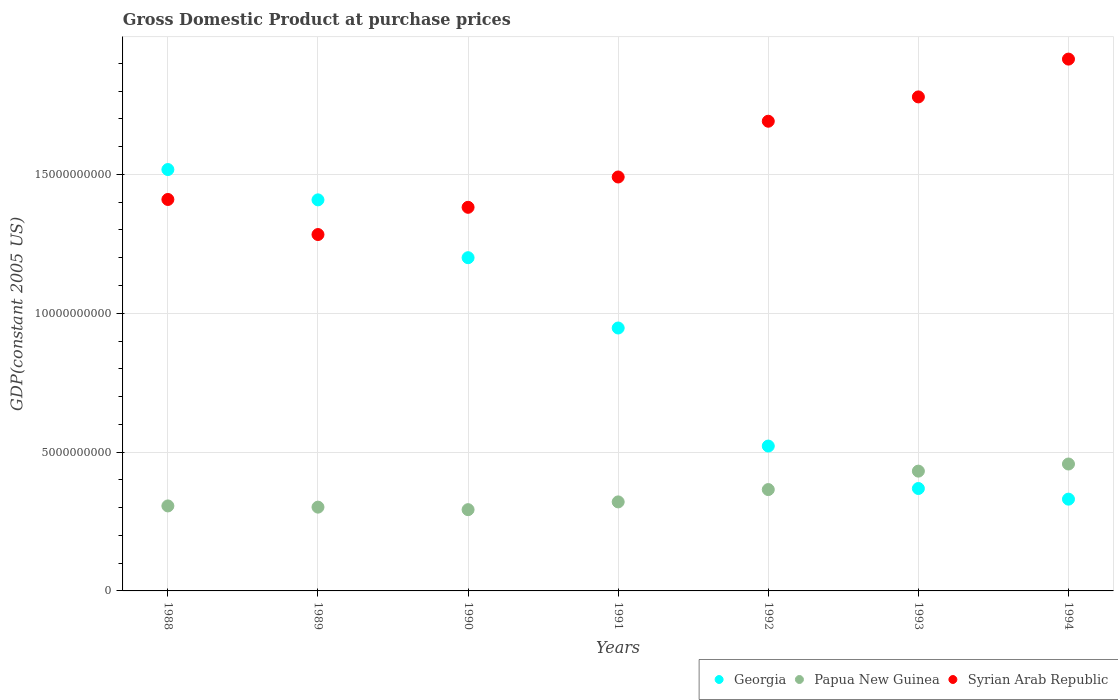How many different coloured dotlines are there?
Provide a short and direct response. 3. Is the number of dotlines equal to the number of legend labels?
Provide a succinct answer. Yes. What is the GDP at purchase prices in Papua New Guinea in 1994?
Your answer should be compact. 4.57e+09. Across all years, what is the maximum GDP at purchase prices in Syrian Arab Republic?
Give a very brief answer. 1.92e+1. Across all years, what is the minimum GDP at purchase prices in Georgia?
Provide a short and direct response. 3.30e+09. What is the total GDP at purchase prices in Georgia in the graph?
Your answer should be compact. 6.29e+1. What is the difference between the GDP at purchase prices in Syrian Arab Republic in 1990 and that in 1991?
Give a very brief answer. -1.09e+09. What is the difference between the GDP at purchase prices in Papua New Guinea in 1991 and the GDP at purchase prices in Syrian Arab Republic in 1994?
Provide a succinct answer. -1.59e+1. What is the average GDP at purchase prices in Papua New Guinea per year?
Offer a terse response. 3.53e+09. In the year 1992, what is the difference between the GDP at purchase prices in Georgia and GDP at purchase prices in Syrian Arab Republic?
Provide a short and direct response. -1.17e+1. What is the ratio of the GDP at purchase prices in Georgia in 1989 to that in 1990?
Keep it short and to the point. 1.17. Is the GDP at purchase prices in Papua New Guinea in 1989 less than that in 1990?
Your answer should be compact. No. Is the difference between the GDP at purchase prices in Georgia in 1988 and 1993 greater than the difference between the GDP at purchase prices in Syrian Arab Republic in 1988 and 1993?
Offer a terse response. Yes. What is the difference between the highest and the second highest GDP at purchase prices in Syrian Arab Republic?
Provide a short and direct response. 1.36e+09. What is the difference between the highest and the lowest GDP at purchase prices in Papua New Guinea?
Offer a very short reply. 1.64e+09. In how many years, is the GDP at purchase prices in Papua New Guinea greater than the average GDP at purchase prices in Papua New Guinea taken over all years?
Ensure brevity in your answer.  3. Is it the case that in every year, the sum of the GDP at purchase prices in Georgia and GDP at purchase prices in Papua New Guinea  is greater than the GDP at purchase prices in Syrian Arab Republic?
Give a very brief answer. No. Does the GDP at purchase prices in Papua New Guinea monotonically increase over the years?
Your response must be concise. No. Is the GDP at purchase prices in Georgia strictly greater than the GDP at purchase prices in Syrian Arab Republic over the years?
Make the answer very short. No. How many years are there in the graph?
Your answer should be compact. 7. Are the values on the major ticks of Y-axis written in scientific E-notation?
Offer a terse response. No. Does the graph contain grids?
Offer a terse response. Yes. What is the title of the graph?
Offer a very short reply. Gross Domestic Product at purchase prices. Does "Panama" appear as one of the legend labels in the graph?
Keep it short and to the point. No. What is the label or title of the Y-axis?
Make the answer very short. GDP(constant 2005 US). What is the GDP(constant 2005 US) in Georgia in 1988?
Make the answer very short. 1.52e+1. What is the GDP(constant 2005 US) of Papua New Guinea in 1988?
Keep it short and to the point. 3.06e+09. What is the GDP(constant 2005 US) of Syrian Arab Republic in 1988?
Offer a very short reply. 1.41e+1. What is the GDP(constant 2005 US) in Georgia in 1989?
Provide a short and direct response. 1.41e+1. What is the GDP(constant 2005 US) of Papua New Guinea in 1989?
Make the answer very short. 3.02e+09. What is the GDP(constant 2005 US) in Syrian Arab Republic in 1989?
Offer a very short reply. 1.28e+1. What is the GDP(constant 2005 US) in Georgia in 1990?
Give a very brief answer. 1.20e+1. What is the GDP(constant 2005 US) in Papua New Guinea in 1990?
Make the answer very short. 2.93e+09. What is the GDP(constant 2005 US) in Syrian Arab Republic in 1990?
Your response must be concise. 1.38e+1. What is the GDP(constant 2005 US) of Georgia in 1991?
Provide a short and direct response. 9.47e+09. What is the GDP(constant 2005 US) of Papua New Guinea in 1991?
Provide a short and direct response. 3.21e+09. What is the GDP(constant 2005 US) in Syrian Arab Republic in 1991?
Ensure brevity in your answer.  1.49e+1. What is the GDP(constant 2005 US) in Georgia in 1992?
Offer a terse response. 5.22e+09. What is the GDP(constant 2005 US) of Papua New Guinea in 1992?
Give a very brief answer. 3.65e+09. What is the GDP(constant 2005 US) in Syrian Arab Republic in 1992?
Your answer should be very brief. 1.69e+1. What is the GDP(constant 2005 US) in Georgia in 1993?
Your answer should be compact. 3.69e+09. What is the GDP(constant 2005 US) of Papua New Guinea in 1993?
Your answer should be compact. 4.31e+09. What is the GDP(constant 2005 US) in Syrian Arab Republic in 1993?
Keep it short and to the point. 1.78e+1. What is the GDP(constant 2005 US) in Georgia in 1994?
Provide a short and direct response. 3.30e+09. What is the GDP(constant 2005 US) of Papua New Guinea in 1994?
Keep it short and to the point. 4.57e+09. What is the GDP(constant 2005 US) of Syrian Arab Republic in 1994?
Your answer should be very brief. 1.92e+1. Across all years, what is the maximum GDP(constant 2005 US) in Georgia?
Give a very brief answer. 1.52e+1. Across all years, what is the maximum GDP(constant 2005 US) in Papua New Guinea?
Give a very brief answer. 4.57e+09. Across all years, what is the maximum GDP(constant 2005 US) in Syrian Arab Republic?
Ensure brevity in your answer.  1.92e+1. Across all years, what is the minimum GDP(constant 2005 US) in Georgia?
Provide a succinct answer. 3.30e+09. Across all years, what is the minimum GDP(constant 2005 US) in Papua New Guinea?
Ensure brevity in your answer.  2.93e+09. Across all years, what is the minimum GDP(constant 2005 US) of Syrian Arab Republic?
Keep it short and to the point. 1.28e+1. What is the total GDP(constant 2005 US) in Georgia in the graph?
Your answer should be very brief. 6.29e+1. What is the total GDP(constant 2005 US) of Papua New Guinea in the graph?
Give a very brief answer. 2.47e+1. What is the total GDP(constant 2005 US) of Syrian Arab Republic in the graph?
Your response must be concise. 1.10e+11. What is the difference between the GDP(constant 2005 US) of Georgia in 1988 and that in 1989?
Offer a very short reply. 1.09e+09. What is the difference between the GDP(constant 2005 US) in Papua New Guinea in 1988 and that in 1989?
Your response must be concise. 4.34e+07. What is the difference between the GDP(constant 2005 US) of Syrian Arab Republic in 1988 and that in 1989?
Your answer should be very brief. 1.26e+09. What is the difference between the GDP(constant 2005 US) in Georgia in 1988 and that in 1990?
Give a very brief answer. 3.17e+09. What is the difference between the GDP(constant 2005 US) of Papua New Guinea in 1988 and that in 1990?
Make the answer very short. 1.34e+08. What is the difference between the GDP(constant 2005 US) of Syrian Arab Republic in 1988 and that in 1990?
Provide a succinct answer. 2.82e+08. What is the difference between the GDP(constant 2005 US) of Georgia in 1988 and that in 1991?
Offer a terse response. 5.71e+09. What is the difference between the GDP(constant 2005 US) in Papua New Guinea in 1988 and that in 1991?
Offer a very short reply. -1.45e+08. What is the difference between the GDP(constant 2005 US) of Syrian Arab Republic in 1988 and that in 1991?
Your answer should be compact. -8.09e+08. What is the difference between the GDP(constant 2005 US) in Georgia in 1988 and that in 1992?
Offer a very short reply. 9.96e+09. What is the difference between the GDP(constant 2005 US) in Papua New Guinea in 1988 and that in 1992?
Your answer should be very brief. -5.89e+08. What is the difference between the GDP(constant 2005 US) of Syrian Arab Republic in 1988 and that in 1992?
Your answer should be very brief. -2.82e+09. What is the difference between the GDP(constant 2005 US) of Georgia in 1988 and that in 1993?
Provide a succinct answer. 1.15e+1. What is the difference between the GDP(constant 2005 US) of Papua New Guinea in 1988 and that in 1993?
Provide a succinct answer. -1.25e+09. What is the difference between the GDP(constant 2005 US) in Syrian Arab Republic in 1988 and that in 1993?
Provide a succinct answer. -3.69e+09. What is the difference between the GDP(constant 2005 US) of Georgia in 1988 and that in 1994?
Keep it short and to the point. 1.19e+1. What is the difference between the GDP(constant 2005 US) of Papua New Guinea in 1988 and that in 1994?
Your answer should be compact. -1.51e+09. What is the difference between the GDP(constant 2005 US) in Syrian Arab Republic in 1988 and that in 1994?
Your response must be concise. -5.05e+09. What is the difference between the GDP(constant 2005 US) of Georgia in 1989 and that in 1990?
Your answer should be compact. 2.08e+09. What is the difference between the GDP(constant 2005 US) of Papua New Guinea in 1989 and that in 1990?
Your answer should be very brief. 9.09e+07. What is the difference between the GDP(constant 2005 US) in Syrian Arab Republic in 1989 and that in 1990?
Keep it short and to the point. -9.81e+08. What is the difference between the GDP(constant 2005 US) in Georgia in 1989 and that in 1991?
Your response must be concise. 4.61e+09. What is the difference between the GDP(constant 2005 US) in Papua New Guinea in 1989 and that in 1991?
Give a very brief answer. -1.88e+08. What is the difference between the GDP(constant 2005 US) of Syrian Arab Republic in 1989 and that in 1991?
Provide a succinct answer. -2.07e+09. What is the difference between the GDP(constant 2005 US) in Georgia in 1989 and that in 1992?
Provide a succinct answer. 8.87e+09. What is the difference between the GDP(constant 2005 US) of Papua New Guinea in 1989 and that in 1992?
Offer a terse response. -6.32e+08. What is the difference between the GDP(constant 2005 US) in Syrian Arab Republic in 1989 and that in 1992?
Keep it short and to the point. -4.08e+09. What is the difference between the GDP(constant 2005 US) of Georgia in 1989 and that in 1993?
Give a very brief answer. 1.04e+1. What is the difference between the GDP(constant 2005 US) of Papua New Guinea in 1989 and that in 1993?
Keep it short and to the point. -1.30e+09. What is the difference between the GDP(constant 2005 US) of Syrian Arab Republic in 1989 and that in 1993?
Ensure brevity in your answer.  -4.96e+09. What is the difference between the GDP(constant 2005 US) of Georgia in 1989 and that in 1994?
Your answer should be very brief. 1.08e+1. What is the difference between the GDP(constant 2005 US) in Papua New Guinea in 1989 and that in 1994?
Your response must be concise. -1.55e+09. What is the difference between the GDP(constant 2005 US) in Syrian Arab Republic in 1989 and that in 1994?
Ensure brevity in your answer.  -6.32e+09. What is the difference between the GDP(constant 2005 US) in Georgia in 1990 and that in 1991?
Make the answer very short. 2.53e+09. What is the difference between the GDP(constant 2005 US) in Papua New Guinea in 1990 and that in 1991?
Your answer should be compact. -2.79e+08. What is the difference between the GDP(constant 2005 US) of Syrian Arab Republic in 1990 and that in 1991?
Provide a succinct answer. -1.09e+09. What is the difference between the GDP(constant 2005 US) in Georgia in 1990 and that in 1992?
Your answer should be compact. 6.78e+09. What is the difference between the GDP(constant 2005 US) in Papua New Guinea in 1990 and that in 1992?
Your answer should be very brief. -7.23e+08. What is the difference between the GDP(constant 2005 US) of Syrian Arab Republic in 1990 and that in 1992?
Keep it short and to the point. -3.10e+09. What is the difference between the GDP(constant 2005 US) in Georgia in 1990 and that in 1993?
Offer a very short reply. 8.31e+09. What is the difference between the GDP(constant 2005 US) in Papua New Guinea in 1990 and that in 1993?
Your answer should be very brief. -1.39e+09. What is the difference between the GDP(constant 2005 US) of Syrian Arab Republic in 1990 and that in 1993?
Make the answer very short. -3.98e+09. What is the difference between the GDP(constant 2005 US) in Georgia in 1990 and that in 1994?
Keep it short and to the point. 8.70e+09. What is the difference between the GDP(constant 2005 US) in Papua New Guinea in 1990 and that in 1994?
Give a very brief answer. -1.64e+09. What is the difference between the GDP(constant 2005 US) of Syrian Arab Republic in 1990 and that in 1994?
Offer a very short reply. -5.34e+09. What is the difference between the GDP(constant 2005 US) of Georgia in 1991 and that in 1992?
Your answer should be compact. 4.25e+09. What is the difference between the GDP(constant 2005 US) of Papua New Guinea in 1991 and that in 1992?
Provide a succinct answer. -4.44e+08. What is the difference between the GDP(constant 2005 US) of Syrian Arab Republic in 1991 and that in 1992?
Give a very brief answer. -2.01e+09. What is the difference between the GDP(constant 2005 US) of Georgia in 1991 and that in 1993?
Give a very brief answer. 5.78e+09. What is the difference between the GDP(constant 2005 US) of Papua New Guinea in 1991 and that in 1993?
Give a very brief answer. -1.11e+09. What is the difference between the GDP(constant 2005 US) of Syrian Arab Republic in 1991 and that in 1993?
Ensure brevity in your answer.  -2.88e+09. What is the difference between the GDP(constant 2005 US) of Georgia in 1991 and that in 1994?
Give a very brief answer. 6.16e+09. What is the difference between the GDP(constant 2005 US) of Papua New Guinea in 1991 and that in 1994?
Your answer should be compact. -1.36e+09. What is the difference between the GDP(constant 2005 US) in Syrian Arab Republic in 1991 and that in 1994?
Your response must be concise. -4.25e+09. What is the difference between the GDP(constant 2005 US) in Georgia in 1992 and that in 1993?
Offer a very short reply. 1.53e+09. What is the difference between the GDP(constant 2005 US) of Papua New Guinea in 1992 and that in 1993?
Provide a short and direct response. -6.64e+08. What is the difference between the GDP(constant 2005 US) of Syrian Arab Republic in 1992 and that in 1993?
Ensure brevity in your answer.  -8.76e+08. What is the difference between the GDP(constant 2005 US) of Georgia in 1992 and that in 1994?
Provide a short and direct response. 1.91e+09. What is the difference between the GDP(constant 2005 US) of Papua New Guinea in 1992 and that in 1994?
Provide a short and direct response. -9.21e+08. What is the difference between the GDP(constant 2005 US) of Syrian Arab Republic in 1992 and that in 1994?
Your answer should be compact. -2.24e+09. What is the difference between the GDP(constant 2005 US) of Georgia in 1993 and that in 1994?
Your answer should be very brief. 3.84e+08. What is the difference between the GDP(constant 2005 US) of Papua New Guinea in 1993 and that in 1994?
Give a very brief answer. -2.56e+08. What is the difference between the GDP(constant 2005 US) of Syrian Arab Republic in 1993 and that in 1994?
Give a very brief answer. -1.36e+09. What is the difference between the GDP(constant 2005 US) in Georgia in 1988 and the GDP(constant 2005 US) in Papua New Guinea in 1989?
Give a very brief answer. 1.22e+1. What is the difference between the GDP(constant 2005 US) in Georgia in 1988 and the GDP(constant 2005 US) in Syrian Arab Republic in 1989?
Provide a succinct answer. 2.34e+09. What is the difference between the GDP(constant 2005 US) of Papua New Guinea in 1988 and the GDP(constant 2005 US) of Syrian Arab Republic in 1989?
Make the answer very short. -9.77e+09. What is the difference between the GDP(constant 2005 US) of Georgia in 1988 and the GDP(constant 2005 US) of Papua New Guinea in 1990?
Your response must be concise. 1.22e+1. What is the difference between the GDP(constant 2005 US) in Georgia in 1988 and the GDP(constant 2005 US) in Syrian Arab Republic in 1990?
Provide a succinct answer. 1.36e+09. What is the difference between the GDP(constant 2005 US) of Papua New Guinea in 1988 and the GDP(constant 2005 US) of Syrian Arab Republic in 1990?
Keep it short and to the point. -1.08e+1. What is the difference between the GDP(constant 2005 US) of Georgia in 1988 and the GDP(constant 2005 US) of Papua New Guinea in 1991?
Offer a very short reply. 1.20e+1. What is the difference between the GDP(constant 2005 US) of Georgia in 1988 and the GDP(constant 2005 US) of Syrian Arab Republic in 1991?
Make the answer very short. 2.68e+08. What is the difference between the GDP(constant 2005 US) in Papua New Guinea in 1988 and the GDP(constant 2005 US) in Syrian Arab Republic in 1991?
Give a very brief answer. -1.18e+1. What is the difference between the GDP(constant 2005 US) in Georgia in 1988 and the GDP(constant 2005 US) in Papua New Guinea in 1992?
Your answer should be very brief. 1.15e+1. What is the difference between the GDP(constant 2005 US) of Georgia in 1988 and the GDP(constant 2005 US) of Syrian Arab Republic in 1992?
Offer a very short reply. -1.74e+09. What is the difference between the GDP(constant 2005 US) in Papua New Guinea in 1988 and the GDP(constant 2005 US) in Syrian Arab Republic in 1992?
Give a very brief answer. -1.39e+1. What is the difference between the GDP(constant 2005 US) in Georgia in 1988 and the GDP(constant 2005 US) in Papua New Guinea in 1993?
Your response must be concise. 1.09e+1. What is the difference between the GDP(constant 2005 US) of Georgia in 1988 and the GDP(constant 2005 US) of Syrian Arab Republic in 1993?
Offer a very short reply. -2.62e+09. What is the difference between the GDP(constant 2005 US) of Papua New Guinea in 1988 and the GDP(constant 2005 US) of Syrian Arab Republic in 1993?
Your answer should be compact. -1.47e+1. What is the difference between the GDP(constant 2005 US) of Georgia in 1988 and the GDP(constant 2005 US) of Papua New Guinea in 1994?
Provide a short and direct response. 1.06e+1. What is the difference between the GDP(constant 2005 US) of Georgia in 1988 and the GDP(constant 2005 US) of Syrian Arab Republic in 1994?
Your answer should be compact. -3.98e+09. What is the difference between the GDP(constant 2005 US) in Papua New Guinea in 1988 and the GDP(constant 2005 US) in Syrian Arab Republic in 1994?
Your answer should be very brief. -1.61e+1. What is the difference between the GDP(constant 2005 US) of Georgia in 1989 and the GDP(constant 2005 US) of Papua New Guinea in 1990?
Ensure brevity in your answer.  1.12e+1. What is the difference between the GDP(constant 2005 US) in Georgia in 1989 and the GDP(constant 2005 US) in Syrian Arab Republic in 1990?
Provide a succinct answer. 2.68e+08. What is the difference between the GDP(constant 2005 US) in Papua New Guinea in 1989 and the GDP(constant 2005 US) in Syrian Arab Republic in 1990?
Your response must be concise. -1.08e+1. What is the difference between the GDP(constant 2005 US) in Georgia in 1989 and the GDP(constant 2005 US) in Papua New Guinea in 1991?
Offer a terse response. 1.09e+1. What is the difference between the GDP(constant 2005 US) in Georgia in 1989 and the GDP(constant 2005 US) in Syrian Arab Republic in 1991?
Your response must be concise. -8.24e+08. What is the difference between the GDP(constant 2005 US) in Papua New Guinea in 1989 and the GDP(constant 2005 US) in Syrian Arab Republic in 1991?
Give a very brief answer. -1.19e+1. What is the difference between the GDP(constant 2005 US) of Georgia in 1989 and the GDP(constant 2005 US) of Papua New Guinea in 1992?
Provide a short and direct response. 1.04e+1. What is the difference between the GDP(constant 2005 US) of Georgia in 1989 and the GDP(constant 2005 US) of Syrian Arab Republic in 1992?
Your answer should be very brief. -2.83e+09. What is the difference between the GDP(constant 2005 US) of Papua New Guinea in 1989 and the GDP(constant 2005 US) of Syrian Arab Republic in 1992?
Provide a short and direct response. -1.39e+1. What is the difference between the GDP(constant 2005 US) in Georgia in 1989 and the GDP(constant 2005 US) in Papua New Guinea in 1993?
Your response must be concise. 9.77e+09. What is the difference between the GDP(constant 2005 US) in Georgia in 1989 and the GDP(constant 2005 US) in Syrian Arab Republic in 1993?
Your answer should be compact. -3.71e+09. What is the difference between the GDP(constant 2005 US) of Papua New Guinea in 1989 and the GDP(constant 2005 US) of Syrian Arab Republic in 1993?
Your answer should be compact. -1.48e+1. What is the difference between the GDP(constant 2005 US) of Georgia in 1989 and the GDP(constant 2005 US) of Papua New Guinea in 1994?
Your response must be concise. 9.51e+09. What is the difference between the GDP(constant 2005 US) of Georgia in 1989 and the GDP(constant 2005 US) of Syrian Arab Republic in 1994?
Offer a very short reply. -5.07e+09. What is the difference between the GDP(constant 2005 US) in Papua New Guinea in 1989 and the GDP(constant 2005 US) in Syrian Arab Republic in 1994?
Your answer should be very brief. -1.61e+1. What is the difference between the GDP(constant 2005 US) in Georgia in 1990 and the GDP(constant 2005 US) in Papua New Guinea in 1991?
Offer a very short reply. 8.79e+09. What is the difference between the GDP(constant 2005 US) in Georgia in 1990 and the GDP(constant 2005 US) in Syrian Arab Republic in 1991?
Give a very brief answer. -2.91e+09. What is the difference between the GDP(constant 2005 US) in Papua New Guinea in 1990 and the GDP(constant 2005 US) in Syrian Arab Republic in 1991?
Keep it short and to the point. -1.20e+1. What is the difference between the GDP(constant 2005 US) in Georgia in 1990 and the GDP(constant 2005 US) in Papua New Guinea in 1992?
Provide a succinct answer. 8.35e+09. What is the difference between the GDP(constant 2005 US) in Georgia in 1990 and the GDP(constant 2005 US) in Syrian Arab Republic in 1992?
Offer a terse response. -4.91e+09. What is the difference between the GDP(constant 2005 US) of Papua New Guinea in 1990 and the GDP(constant 2005 US) of Syrian Arab Republic in 1992?
Give a very brief answer. -1.40e+1. What is the difference between the GDP(constant 2005 US) in Georgia in 1990 and the GDP(constant 2005 US) in Papua New Guinea in 1993?
Provide a succinct answer. 7.69e+09. What is the difference between the GDP(constant 2005 US) in Georgia in 1990 and the GDP(constant 2005 US) in Syrian Arab Republic in 1993?
Your response must be concise. -5.79e+09. What is the difference between the GDP(constant 2005 US) in Papua New Guinea in 1990 and the GDP(constant 2005 US) in Syrian Arab Republic in 1993?
Make the answer very short. -1.49e+1. What is the difference between the GDP(constant 2005 US) in Georgia in 1990 and the GDP(constant 2005 US) in Papua New Guinea in 1994?
Offer a terse response. 7.43e+09. What is the difference between the GDP(constant 2005 US) of Georgia in 1990 and the GDP(constant 2005 US) of Syrian Arab Republic in 1994?
Offer a terse response. -7.15e+09. What is the difference between the GDP(constant 2005 US) of Papua New Guinea in 1990 and the GDP(constant 2005 US) of Syrian Arab Republic in 1994?
Offer a very short reply. -1.62e+1. What is the difference between the GDP(constant 2005 US) in Georgia in 1991 and the GDP(constant 2005 US) in Papua New Guinea in 1992?
Ensure brevity in your answer.  5.82e+09. What is the difference between the GDP(constant 2005 US) in Georgia in 1991 and the GDP(constant 2005 US) in Syrian Arab Republic in 1992?
Give a very brief answer. -7.45e+09. What is the difference between the GDP(constant 2005 US) in Papua New Guinea in 1991 and the GDP(constant 2005 US) in Syrian Arab Republic in 1992?
Provide a short and direct response. -1.37e+1. What is the difference between the GDP(constant 2005 US) of Georgia in 1991 and the GDP(constant 2005 US) of Papua New Guinea in 1993?
Your answer should be compact. 5.15e+09. What is the difference between the GDP(constant 2005 US) in Georgia in 1991 and the GDP(constant 2005 US) in Syrian Arab Republic in 1993?
Give a very brief answer. -8.32e+09. What is the difference between the GDP(constant 2005 US) of Papua New Guinea in 1991 and the GDP(constant 2005 US) of Syrian Arab Republic in 1993?
Your answer should be very brief. -1.46e+1. What is the difference between the GDP(constant 2005 US) of Georgia in 1991 and the GDP(constant 2005 US) of Papua New Guinea in 1994?
Provide a short and direct response. 4.90e+09. What is the difference between the GDP(constant 2005 US) in Georgia in 1991 and the GDP(constant 2005 US) in Syrian Arab Republic in 1994?
Keep it short and to the point. -9.68e+09. What is the difference between the GDP(constant 2005 US) of Papua New Guinea in 1991 and the GDP(constant 2005 US) of Syrian Arab Republic in 1994?
Offer a very short reply. -1.59e+1. What is the difference between the GDP(constant 2005 US) in Georgia in 1992 and the GDP(constant 2005 US) in Papua New Guinea in 1993?
Make the answer very short. 9.03e+08. What is the difference between the GDP(constant 2005 US) of Georgia in 1992 and the GDP(constant 2005 US) of Syrian Arab Republic in 1993?
Provide a succinct answer. -1.26e+1. What is the difference between the GDP(constant 2005 US) in Papua New Guinea in 1992 and the GDP(constant 2005 US) in Syrian Arab Republic in 1993?
Provide a short and direct response. -1.41e+1. What is the difference between the GDP(constant 2005 US) in Georgia in 1992 and the GDP(constant 2005 US) in Papua New Guinea in 1994?
Your answer should be very brief. 6.47e+08. What is the difference between the GDP(constant 2005 US) in Georgia in 1992 and the GDP(constant 2005 US) in Syrian Arab Republic in 1994?
Make the answer very short. -1.39e+1. What is the difference between the GDP(constant 2005 US) of Papua New Guinea in 1992 and the GDP(constant 2005 US) of Syrian Arab Republic in 1994?
Offer a terse response. -1.55e+1. What is the difference between the GDP(constant 2005 US) in Georgia in 1993 and the GDP(constant 2005 US) in Papua New Guinea in 1994?
Ensure brevity in your answer.  -8.82e+08. What is the difference between the GDP(constant 2005 US) in Georgia in 1993 and the GDP(constant 2005 US) in Syrian Arab Republic in 1994?
Give a very brief answer. -1.55e+1. What is the difference between the GDP(constant 2005 US) of Papua New Guinea in 1993 and the GDP(constant 2005 US) of Syrian Arab Republic in 1994?
Ensure brevity in your answer.  -1.48e+1. What is the average GDP(constant 2005 US) of Georgia per year?
Ensure brevity in your answer.  8.99e+09. What is the average GDP(constant 2005 US) of Papua New Guinea per year?
Provide a short and direct response. 3.53e+09. What is the average GDP(constant 2005 US) in Syrian Arab Republic per year?
Keep it short and to the point. 1.56e+1. In the year 1988, what is the difference between the GDP(constant 2005 US) of Georgia and GDP(constant 2005 US) of Papua New Guinea?
Ensure brevity in your answer.  1.21e+1. In the year 1988, what is the difference between the GDP(constant 2005 US) in Georgia and GDP(constant 2005 US) in Syrian Arab Republic?
Offer a terse response. 1.08e+09. In the year 1988, what is the difference between the GDP(constant 2005 US) of Papua New Guinea and GDP(constant 2005 US) of Syrian Arab Republic?
Keep it short and to the point. -1.10e+1. In the year 1989, what is the difference between the GDP(constant 2005 US) of Georgia and GDP(constant 2005 US) of Papua New Guinea?
Offer a terse response. 1.11e+1. In the year 1989, what is the difference between the GDP(constant 2005 US) of Georgia and GDP(constant 2005 US) of Syrian Arab Republic?
Your answer should be very brief. 1.25e+09. In the year 1989, what is the difference between the GDP(constant 2005 US) of Papua New Guinea and GDP(constant 2005 US) of Syrian Arab Republic?
Provide a succinct answer. -9.82e+09. In the year 1990, what is the difference between the GDP(constant 2005 US) in Georgia and GDP(constant 2005 US) in Papua New Guinea?
Your response must be concise. 9.07e+09. In the year 1990, what is the difference between the GDP(constant 2005 US) of Georgia and GDP(constant 2005 US) of Syrian Arab Republic?
Make the answer very short. -1.81e+09. In the year 1990, what is the difference between the GDP(constant 2005 US) in Papua New Guinea and GDP(constant 2005 US) in Syrian Arab Republic?
Ensure brevity in your answer.  -1.09e+1. In the year 1991, what is the difference between the GDP(constant 2005 US) in Georgia and GDP(constant 2005 US) in Papua New Guinea?
Offer a very short reply. 6.26e+09. In the year 1991, what is the difference between the GDP(constant 2005 US) of Georgia and GDP(constant 2005 US) of Syrian Arab Republic?
Ensure brevity in your answer.  -5.44e+09. In the year 1991, what is the difference between the GDP(constant 2005 US) of Papua New Guinea and GDP(constant 2005 US) of Syrian Arab Republic?
Provide a short and direct response. -1.17e+1. In the year 1992, what is the difference between the GDP(constant 2005 US) of Georgia and GDP(constant 2005 US) of Papua New Guinea?
Keep it short and to the point. 1.57e+09. In the year 1992, what is the difference between the GDP(constant 2005 US) of Georgia and GDP(constant 2005 US) of Syrian Arab Republic?
Your answer should be compact. -1.17e+1. In the year 1992, what is the difference between the GDP(constant 2005 US) of Papua New Guinea and GDP(constant 2005 US) of Syrian Arab Republic?
Provide a short and direct response. -1.33e+1. In the year 1993, what is the difference between the GDP(constant 2005 US) in Georgia and GDP(constant 2005 US) in Papua New Guinea?
Provide a short and direct response. -6.26e+08. In the year 1993, what is the difference between the GDP(constant 2005 US) of Georgia and GDP(constant 2005 US) of Syrian Arab Republic?
Provide a succinct answer. -1.41e+1. In the year 1993, what is the difference between the GDP(constant 2005 US) of Papua New Guinea and GDP(constant 2005 US) of Syrian Arab Republic?
Make the answer very short. -1.35e+1. In the year 1994, what is the difference between the GDP(constant 2005 US) of Georgia and GDP(constant 2005 US) of Papua New Guinea?
Keep it short and to the point. -1.27e+09. In the year 1994, what is the difference between the GDP(constant 2005 US) in Georgia and GDP(constant 2005 US) in Syrian Arab Republic?
Give a very brief answer. -1.58e+1. In the year 1994, what is the difference between the GDP(constant 2005 US) of Papua New Guinea and GDP(constant 2005 US) of Syrian Arab Republic?
Provide a short and direct response. -1.46e+1. What is the ratio of the GDP(constant 2005 US) of Georgia in 1988 to that in 1989?
Provide a short and direct response. 1.08. What is the ratio of the GDP(constant 2005 US) of Papua New Guinea in 1988 to that in 1989?
Provide a short and direct response. 1.01. What is the ratio of the GDP(constant 2005 US) in Syrian Arab Republic in 1988 to that in 1989?
Make the answer very short. 1.1. What is the ratio of the GDP(constant 2005 US) of Georgia in 1988 to that in 1990?
Ensure brevity in your answer.  1.26. What is the ratio of the GDP(constant 2005 US) in Papua New Guinea in 1988 to that in 1990?
Offer a very short reply. 1.05. What is the ratio of the GDP(constant 2005 US) of Syrian Arab Republic in 1988 to that in 1990?
Give a very brief answer. 1.02. What is the ratio of the GDP(constant 2005 US) in Georgia in 1988 to that in 1991?
Give a very brief answer. 1.6. What is the ratio of the GDP(constant 2005 US) of Papua New Guinea in 1988 to that in 1991?
Make the answer very short. 0.95. What is the ratio of the GDP(constant 2005 US) in Syrian Arab Republic in 1988 to that in 1991?
Keep it short and to the point. 0.95. What is the ratio of the GDP(constant 2005 US) of Georgia in 1988 to that in 1992?
Ensure brevity in your answer.  2.91. What is the ratio of the GDP(constant 2005 US) of Papua New Guinea in 1988 to that in 1992?
Provide a short and direct response. 0.84. What is the ratio of the GDP(constant 2005 US) of Syrian Arab Republic in 1988 to that in 1992?
Offer a very short reply. 0.83. What is the ratio of the GDP(constant 2005 US) in Georgia in 1988 to that in 1993?
Provide a short and direct response. 4.11. What is the ratio of the GDP(constant 2005 US) in Papua New Guinea in 1988 to that in 1993?
Ensure brevity in your answer.  0.71. What is the ratio of the GDP(constant 2005 US) of Syrian Arab Republic in 1988 to that in 1993?
Make the answer very short. 0.79. What is the ratio of the GDP(constant 2005 US) of Georgia in 1988 to that in 1994?
Offer a terse response. 4.59. What is the ratio of the GDP(constant 2005 US) in Papua New Guinea in 1988 to that in 1994?
Offer a very short reply. 0.67. What is the ratio of the GDP(constant 2005 US) in Syrian Arab Republic in 1988 to that in 1994?
Provide a succinct answer. 0.74. What is the ratio of the GDP(constant 2005 US) of Georgia in 1989 to that in 1990?
Your answer should be very brief. 1.17. What is the ratio of the GDP(constant 2005 US) of Papua New Guinea in 1989 to that in 1990?
Your answer should be very brief. 1.03. What is the ratio of the GDP(constant 2005 US) in Syrian Arab Republic in 1989 to that in 1990?
Give a very brief answer. 0.93. What is the ratio of the GDP(constant 2005 US) in Georgia in 1989 to that in 1991?
Your answer should be compact. 1.49. What is the ratio of the GDP(constant 2005 US) in Syrian Arab Republic in 1989 to that in 1991?
Keep it short and to the point. 0.86. What is the ratio of the GDP(constant 2005 US) of Georgia in 1989 to that in 1992?
Your response must be concise. 2.7. What is the ratio of the GDP(constant 2005 US) in Papua New Guinea in 1989 to that in 1992?
Keep it short and to the point. 0.83. What is the ratio of the GDP(constant 2005 US) in Syrian Arab Republic in 1989 to that in 1992?
Give a very brief answer. 0.76. What is the ratio of the GDP(constant 2005 US) of Georgia in 1989 to that in 1993?
Give a very brief answer. 3.82. What is the ratio of the GDP(constant 2005 US) in Papua New Guinea in 1989 to that in 1993?
Ensure brevity in your answer.  0.7. What is the ratio of the GDP(constant 2005 US) in Syrian Arab Republic in 1989 to that in 1993?
Provide a short and direct response. 0.72. What is the ratio of the GDP(constant 2005 US) in Georgia in 1989 to that in 1994?
Make the answer very short. 4.26. What is the ratio of the GDP(constant 2005 US) of Papua New Guinea in 1989 to that in 1994?
Provide a short and direct response. 0.66. What is the ratio of the GDP(constant 2005 US) of Syrian Arab Republic in 1989 to that in 1994?
Offer a very short reply. 0.67. What is the ratio of the GDP(constant 2005 US) of Georgia in 1990 to that in 1991?
Your answer should be compact. 1.27. What is the ratio of the GDP(constant 2005 US) in Papua New Guinea in 1990 to that in 1991?
Offer a very short reply. 0.91. What is the ratio of the GDP(constant 2005 US) in Syrian Arab Republic in 1990 to that in 1991?
Provide a short and direct response. 0.93. What is the ratio of the GDP(constant 2005 US) of Georgia in 1990 to that in 1992?
Your answer should be very brief. 2.3. What is the ratio of the GDP(constant 2005 US) of Papua New Guinea in 1990 to that in 1992?
Provide a succinct answer. 0.8. What is the ratio of the GDP(constant 2005 US) in Syrian Arab Republic in 1990 to that in 1992?
Make the answer very short. 0.82. What is the ratio of the GDP(constant 2005 US) in Georgia in 1990 to that in 1993?
Give a very brief answer. 3.25. What is the ratio of the GDP(constant 2005 US) of Papua New Guinea in 1990 to that in 1993?
Make the answer very short. 0.68. What is the ratio of the GDP(constant 2005 US) in Syrian Arab Republic in 1990 to that in 1993?
Ensure brevity in your answer.  0.78. What is the ratio of the GDP(constant 2005 US) of Georgia in 1990 to that in 1994?
Keep it short and to the point. 3.63. What is the ratio of the GDP(constant 2005 US) of Papua New Guinea in 1990 to that in 1994?
Your answer should be compact. 0.64. What is the ratio of the GDP(constant 2005 US) of Syrian Arab Republic in 1990 to that in 1994?
Keep it short and to the point. 0.72. What is the ratio of the GDP(constant 2005 US) of Georgia in 1991 to that in 1992?
Offer a very short reply. 1.81. What is the ratio of the GDP(constant 2005 US) of Papua New Guinea in 1991 to that in 1992?
Provide a succinct answer. 0.88. What is the ratio of the GDP(constant 2005 US) of Syrian Arab Republic in 1991 to that in 1992?
Your response must be concise. 0.88. What is the ratio of the GDP(constant 2005 US) in Georgia in 1991 to that in 1993?
Offer a terse response. 2.57. What is the ratio of the GDP(constant 2005 US) of Papua New Guinea in 1991 to that in 1993?
Offer a terse response. 0.74. What is the ratio of the GDP(constant 2005 US) in Syrian Arab Republic in 1991 to that in 1993?
Provide a succinct answer. 0.84. What is the ratio of the GDP(constant 2005 US) of Georgia in 1991 to that in 1994?
Offer a very short reply. 2.87. What is the ratio of the GDP(constant 2005 US) of Papua New Guinea in 1991 to that in 1994?
Make the answer very short. 0.7. What is the ratio of the GDP(constant 2005 US) of Syrian Arab Republic in 1991 to that in 1994?
Offer a very short reply. 0.78. What is the ratio of the GDP(constant 2005 US) of Georgia in 1992 to that in 1993?
Your answer should be compact. 1.41. What is the ratio of the GDP(constant 2005 US) of Papua New Guinea in 1992 to that in 1993?
Your response must be concise. 0.85. What is the ratio of the GDP(constant 2005 US) in Syrian Arab Republic in 1992 to that in 1993?
Provide a succinct answer. 0.95. What is the ratio of the GDP(constant 2005 US) of Georgia in 1992 to that in 1994?
Offer a terse response. 1.58. What is the ratio of the GDP(constant 2005 US) of Papua New Guinea in 1992 to that in 1994?
Your response must be concise. 0.8. What is the ratio of the GDP(constant 2005 US) in Syrian Arab Republic in 1992 to that in 1994?
Your answer should be compact. 0.88. What is the ratio of the GDP(constant 2005 US) in Georgia in 1993 to that in 1994?
Provide a short and direct response. 1.12. What is the ratio of the GDP(constant 2005 US) of Papua New Guinea in 1993 to that in 1994?
Your answer should be compact. 0.94. What is the ratio of the GDP(constant 2005 US) in Syrian Arab Republic in 1993 to that in 1994?
Your answer should be very brief. 0.93. What is the difference between the highest and the second highest GDP(constant 2005 US) in Georgia?
Your answer should be compact. 1.09e+09. What is the difference between the highest and the second highest GDP(constant 2005 US) in Papua New Guinea?
Your answer should be compact. 2.56e+08. What is the difference between the highest and the second highest GDP(constant 2005 US) in Syrian Arab Republic?
Provide a short and direct response. 1.36e+09. What is the difference between the highest and the lowest GDP(constant 2005 US) of Georgia?
Provide a short and direct response. 1.19e+1. What is the difference between the highest and the lowest GDP(constant 2005 US) in Papua New Guinea?
Make the answer very short. 1.64e+09. What is the difference between the highest and the lowest GDP(constant 2005 US) in Syrian Arab Republic?
Your response must be concise. 6.32e+09. 